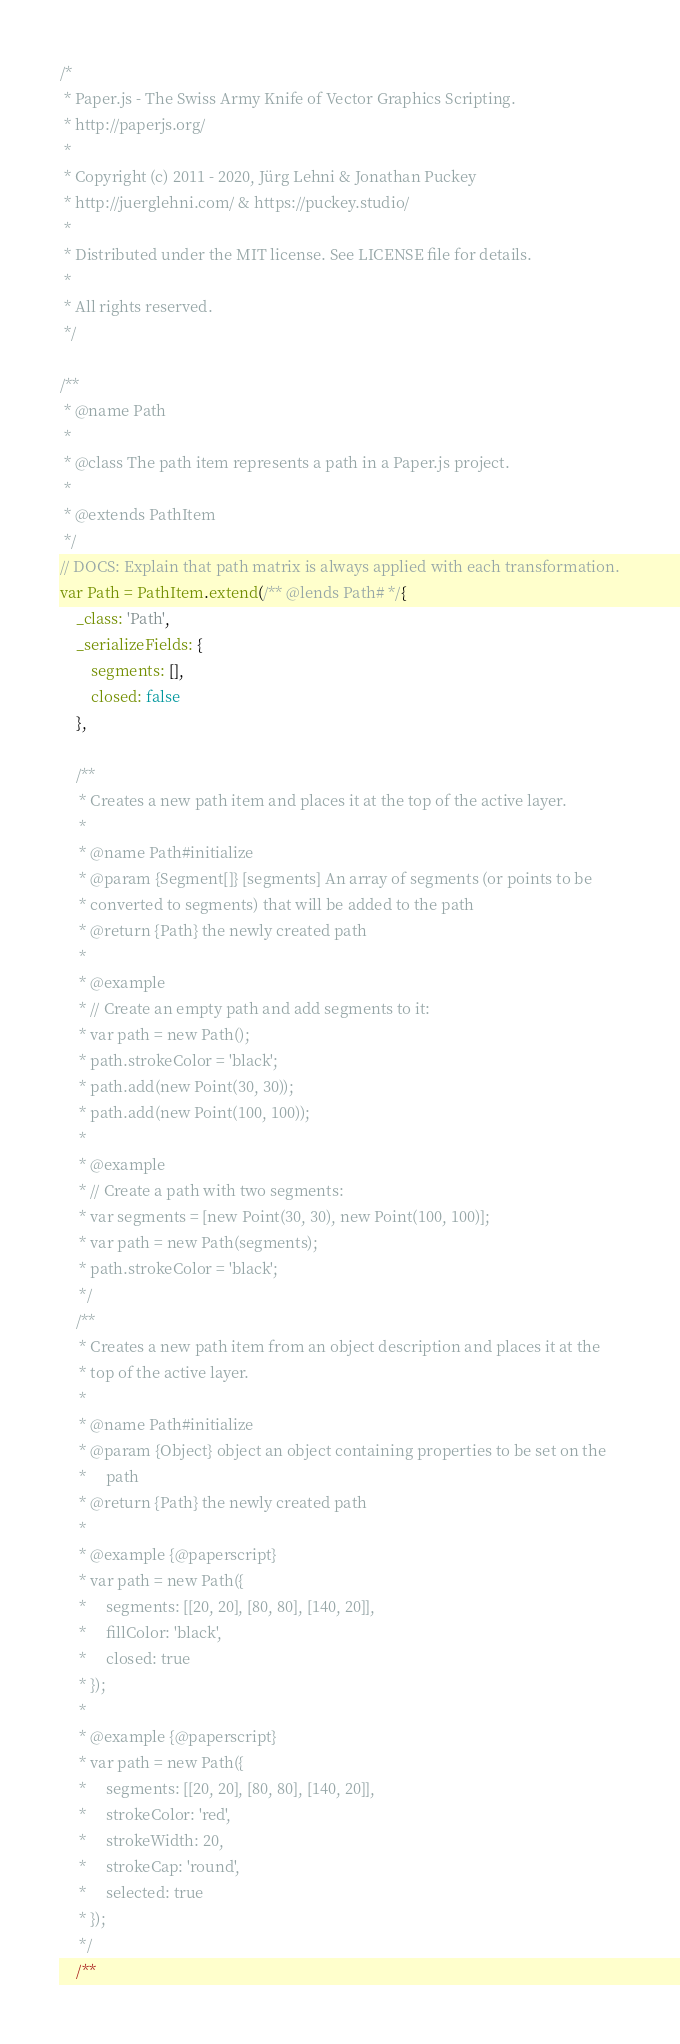Convert code to text. <code><loc_0><loc_0><loc_500><loc_500><_JavaScript_>/*
 * Paper.js - The Swiss Army Knife of Vector Graphics Scripting.
 * http://paperjs.org/
 *
 * Copyright (c) 2011 - 2020, Jürg Lehni & Jonathan Puckey
 * http://juerglehni.com/ & https://puckey.studio/
 *
 * Distributed under the MIT license. See LICENSE file for details.
 *
 * All rights reserved.
 */

/**
 * @name Path
 *
 * @class The path item represents a path in a Paper.js project.
 *
 * @extends PathItem
 */
// DOCS: Explain that path matrix is always applied with each transformation.
var Path = PathItem.extend(/** @lends Path# */{
    _class: 'Path',
    _serializeFields: {
        segments: [],
        closed: false
    },

    /**
     * Creates a new path item and places it at the top of the active layer.
     *
     * @name Path#initialize
     * @param {Segment[]} [segments] An array of segments (or points to be
     * converted to segments) that will be added to the path
     * @return {Path} the newly created path
     *
     * @example
     * // Create an empty path and add segments to it:
     * var path = new Path();
     * path.strokeColor = 'black';
     * path.add(new Point(30, 30));
     * path.add(new Point(100, 100));
     *
     * @example
     * // Create a path with two segments:
     * var segments = [new Point(30, 30), new Point(100, 100)];
     * var path = new Path(segments);
     * path.strokeColor = 'black';
     */
    /**
     * Creates a new path item from an object description and places it at the
     * top of the active layer.
     *
     * @name Path#initialize
     * @param {Object} object an object containing properties to be set on the
     *     path
     * @return {Path} the newly created path
     *
     * @example {@paperscript}
     * var path = new Path({
     *     segments: [[20, 20], [80, 80], [140, 20]],
     *     fillColor: 'black',
     *     closed: true
     * });
     *
     * @example {@paperscript}
     * var path = new Path({
     *     segments: [[20, 20], [80, 80], [140, 20]],
     *     strokeColor: 'red',
     *     strokeWidth: 20,
     *     strokeCap: 'round',
     *     selected: true
     * });
     */
    /**</code> 